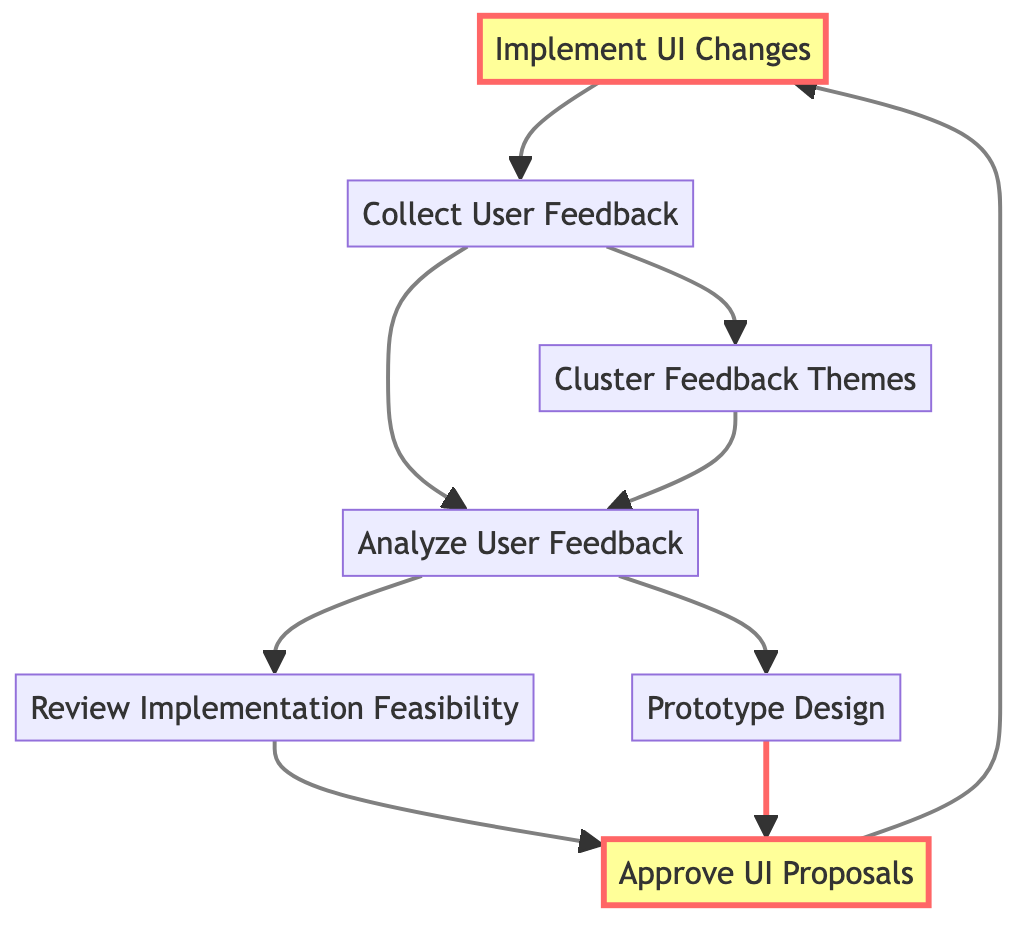What is the starting point of the flowchart? The flowchart starts at the "Collect User Feedback" node, which has no dependencies preventing it from execution. It's the first action in the process.
Answer: Collect User Feedback How many nodes are in the flowchart? The flowchart contains a total of 7 nodes, which represent the different steps in the User Feedback Collection and Analysis Loop.
Answer: 7 Which node comes directly after "Review Implementation Feasibility"? After "Review Implementation Feasibility," the next node is "Approve UI Proposals," as it depends on the completion of the feasibility review.
Answer: Approve UI Proposals What is the last step in the flowchart? The final step is "Implement UI Changes," which occurs after the "Approve UI Proposals" step is completed and approved changes are deployed.
Answer: Implement UI Changes Which two nodes feed into "Analyze User Feedback"? "Collect User Feedback" and "Cluster Feedback Themes" both feed into "Analyze User Feedback," as they provide the necessary data for analysis.
Answer: Collect User Feedback, Cluster Feedback Themes How many edges are present in the flowchart? The flowchart has a total of 8 edges, indicating the directional flow from one step to another throughout the process.
Answer: 8 What is the relationship between "Prototype Design" and "Approve UI Proposals"? "Prototype Design" must be completed before reaching "Approve UI Proposals," as the approvals depend on the designs created.
Answer: Prototype Design Which step involves gathering user feedback? The step that involves gathering user feedback is "Collect User Feedback," as it is specifically aimed at collecting feedback through various channels.
Answer: Collect User Feedback 